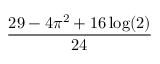Convert formula to latex. <formula><loc_0><loc_0><loc_500><loc_500>\frac { 2 9 - 4 \pi ^ { 2 } + 1 6 \log ( 2 ) } { 2 4 }</formula> 